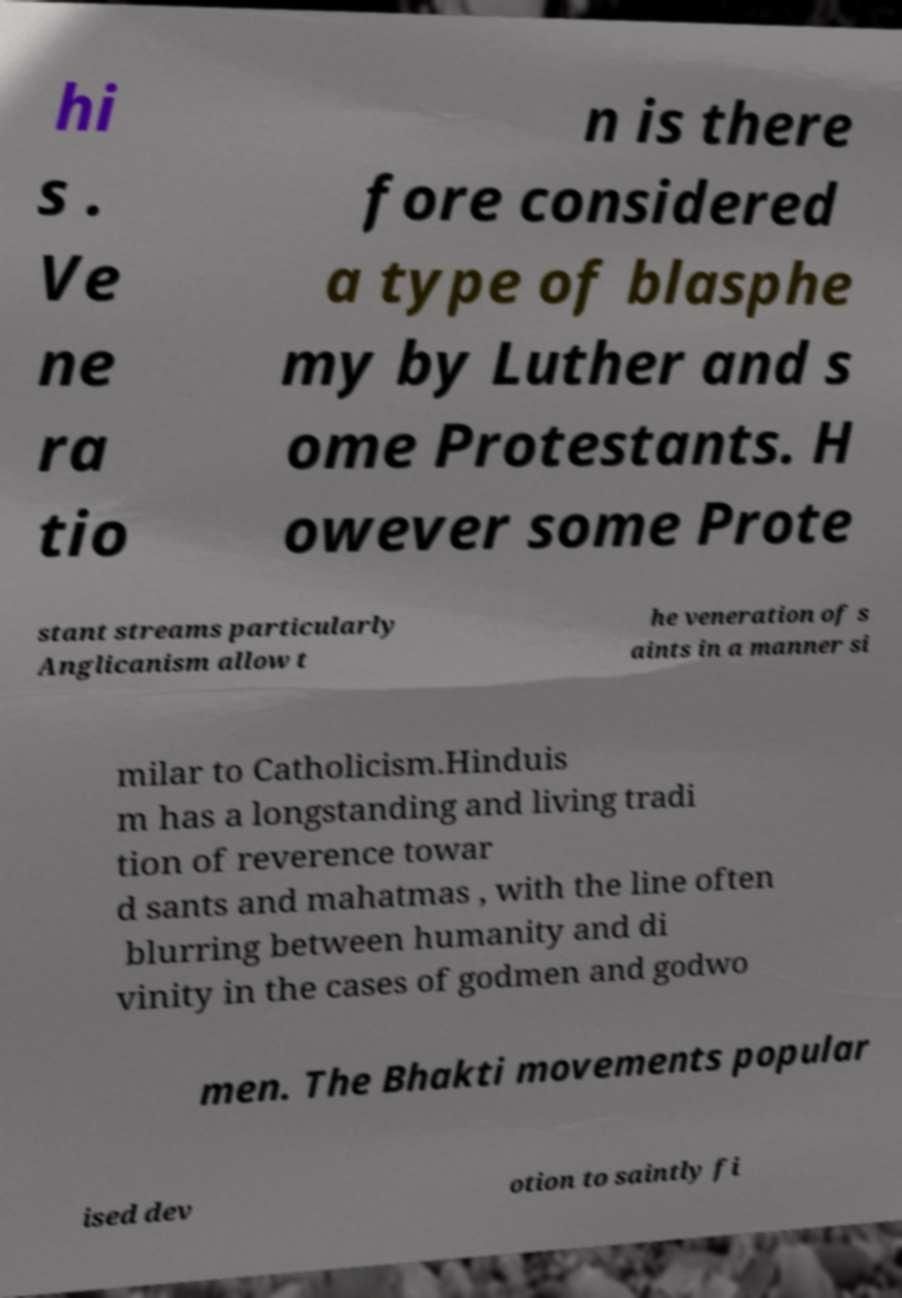Can you accurately transcribe the text from the provided image for me? hi s . Ve ne ra tio n is there fore considered a type of blasphe my by Luther and s ome Protestants. H owever some Prote stant streams particularly Anglicanism allow t he veneration of s aints in a manner si milar to Catholicism.Hinduis m has a longstanding and living tradi tion of reverence towar d sants and mahatmas , with the line often blurring between humanity and di vinity in the cases of godmen and godwo men. The Bhakti movements popular ised dev otion to saintly fi 